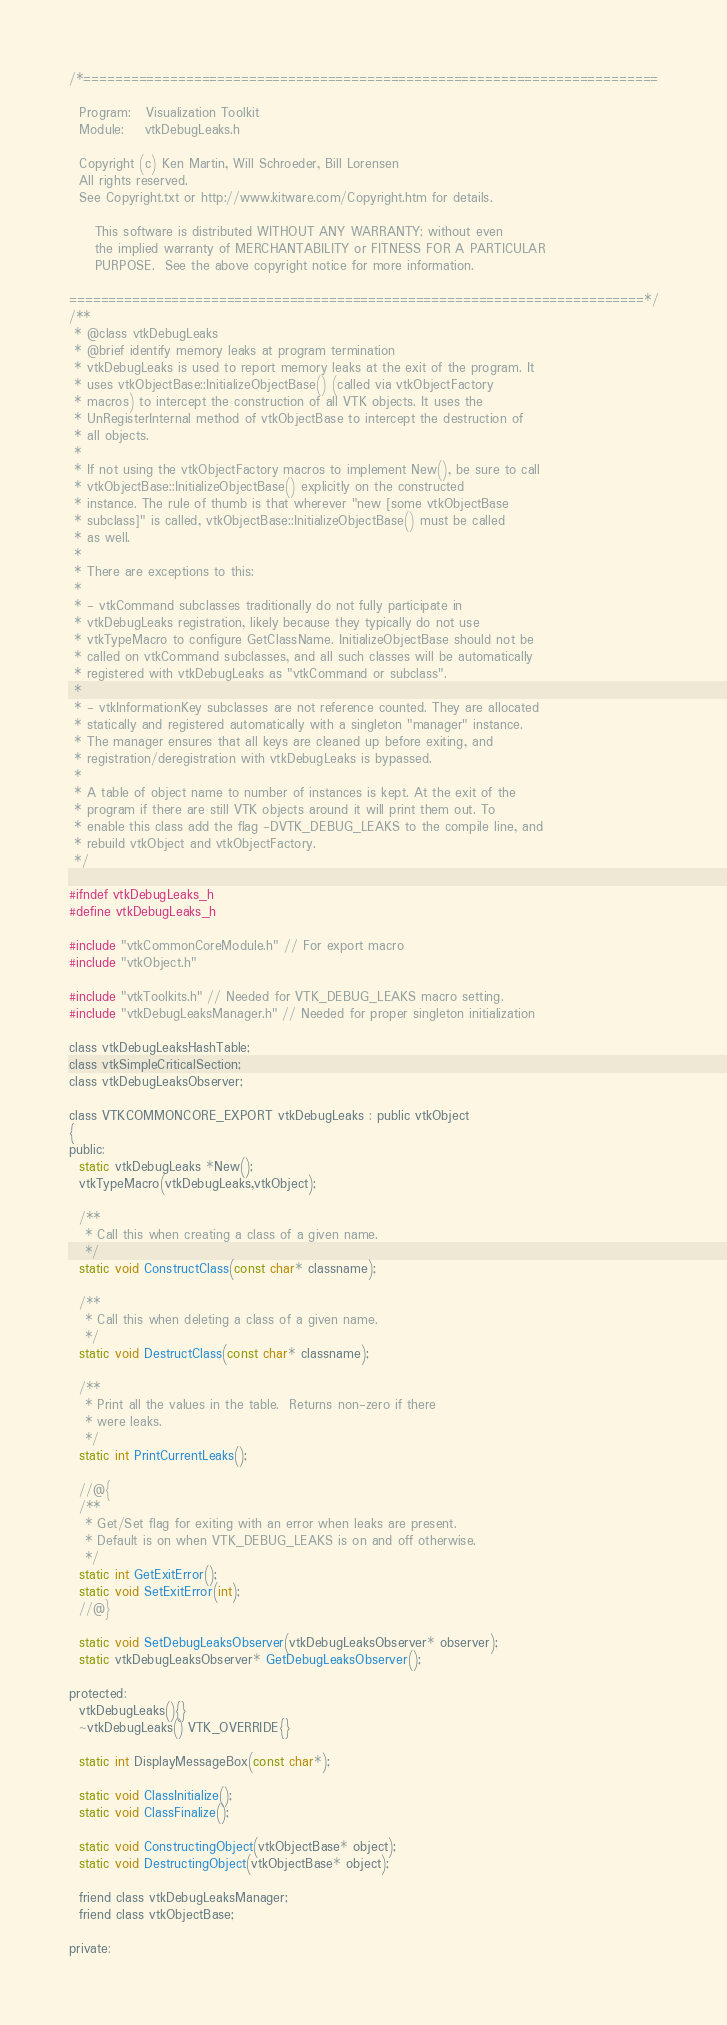Convert code to text. <code><loc_0><loc_0><loc_500><loc_500><_C_>/*=========================================================================

  Program:   Visualization Toolkit
  Module:    vtkDebugLeaks.h

  Copyright (c) Ken Martin, Will Schroeder, Bill Lorensen
  All rights reserved.
  See Copyright.txt or http://www.kitware.com/Copyright.htm for details.

     This software is distributed WITHOUT ANY WARRANTY; without even
     the implied warranty of MERCHANTABILITY or FITNESS FOR A PARTICULAR
     PURPOSE.  See the above copyright notice for more information.

=========================================================================*/
/**
 * @class vtkDebugLeaks
 * @brief identify memory leaks at program termination
 * vtkDebugLeaks is used to report memory leaks at the exit of the program. It
 * uses vtkObjectBase::InitializeObjectBase() (called via vtkObjectFactory
 * macros) to intercept the construction of all VTK objects. It uses the
 * UnRegisterInternal method of vtkObjectBase to intercept the destruction of
 * all objects.
 *
 * If not using the vtkObjectFactory macros to implement New(), be sure to call
 * vtkObjectBase::InitializeObjectBase() explicitly on the constructed
 * instance. The rule of thumb is that wherever "new [some vtkObjectBase
 * subclass]" is called, vtkObjectBase::InitializeObjectBase() must be called
 * as well.
 *
 * There are exceptions to this:
 *
 * - vtkCommand subclasses traditionally do not fully participate in
 * vtkDebugLeaks registration, likely because they typically do not use
 * vtkTypeMacro to configure GetClassName. InitializeObjectBase should not be
 * called on vtkCommand subclasses, and all such classes will be automatically
 * registered with vtkDebugLeaks as "vtkCommand or subclass".
 *
 * - vtkInformationKey subclasses are not reference counted. They are allocated
 * statically and registered automatically with a singleton "manager" instance.
 * The manager ensures that all keys are cleaned up before exiting, and
 * registration/deregistration with vtkDebugLeaks is bypassed.
 *
 * A table of object name to number of instances is kept. At the exit of the
 * program if there are still VTK objects around it will print them out. To
 * enable this class add the flag -DVTK_DEBUG_LEAKS to the compile line, and
 * rebuild vtkObject and vtkObjectFactory.
 */

#ifndef vtkDebugLeaks_h
#define vtkDebugLeaks_h

#include "vtkCommonCoreModule.h" // For export macro
#include "vtkObject.h"

#include "vtkToolkits.h" // Needed for VTK_DEBUG_LEAKS macro setting.
#include "vtkDebugLeaksManager.h" // Needed for proper singleton initialization

class vtkDebugLeaksHashTable;
class vtkSimpleCriticalSection;
class vtkDebugLeaksObserver;

class VTKCOMMONCORE_EXPORT vtkDebugLeaks : public vtkObject
{
public:
  static vtkDebugLeaks *New();
  vtkTypeMacro(vtkDebugLeaks,vtkObject);

  /**
   * Call this when creating a class of a given name.
   */
  static void ConstructClass(const char* classname);

  /**
   * Call this when deleting a class of a given name.
   */
  static void DestructClass(const char* classname);

  /**
   * Print all the values in the table.  Returns non-zero if there
   * were leaks.
   */
  static int PrintCurrentLeaks();

  //@{
  /**
   * Get/Set flag for exiting with an error when leaks are present.
   * Default is on when VTK_DEBUG_LEAKS is on and off otherwise.
   */
  static int GetExitError();
  static void SetExitError(int);
  //@}

  static void SetDebugLeaksObserver(vtkDebugLeaksObserver* observer);
  static vtkDebugLeaksObserver* GetDebugLeaksObserver();

protected:
  vtkDebugLeaks(){}
  ~vtkDebugLeaks() VTK_OVERRIDE{}

  static int DisplayMessageBox(const char*);

  static void ClassInitialize();
  static void ClassFinalize();

  static void ConstructingObject(vtkObjectBase* object);
  static void DestructingObject(vtkObjectBase* object);

  friend class vtkDebugLeaksManager;
  friend class vtkObjectBase;

private:</code> 